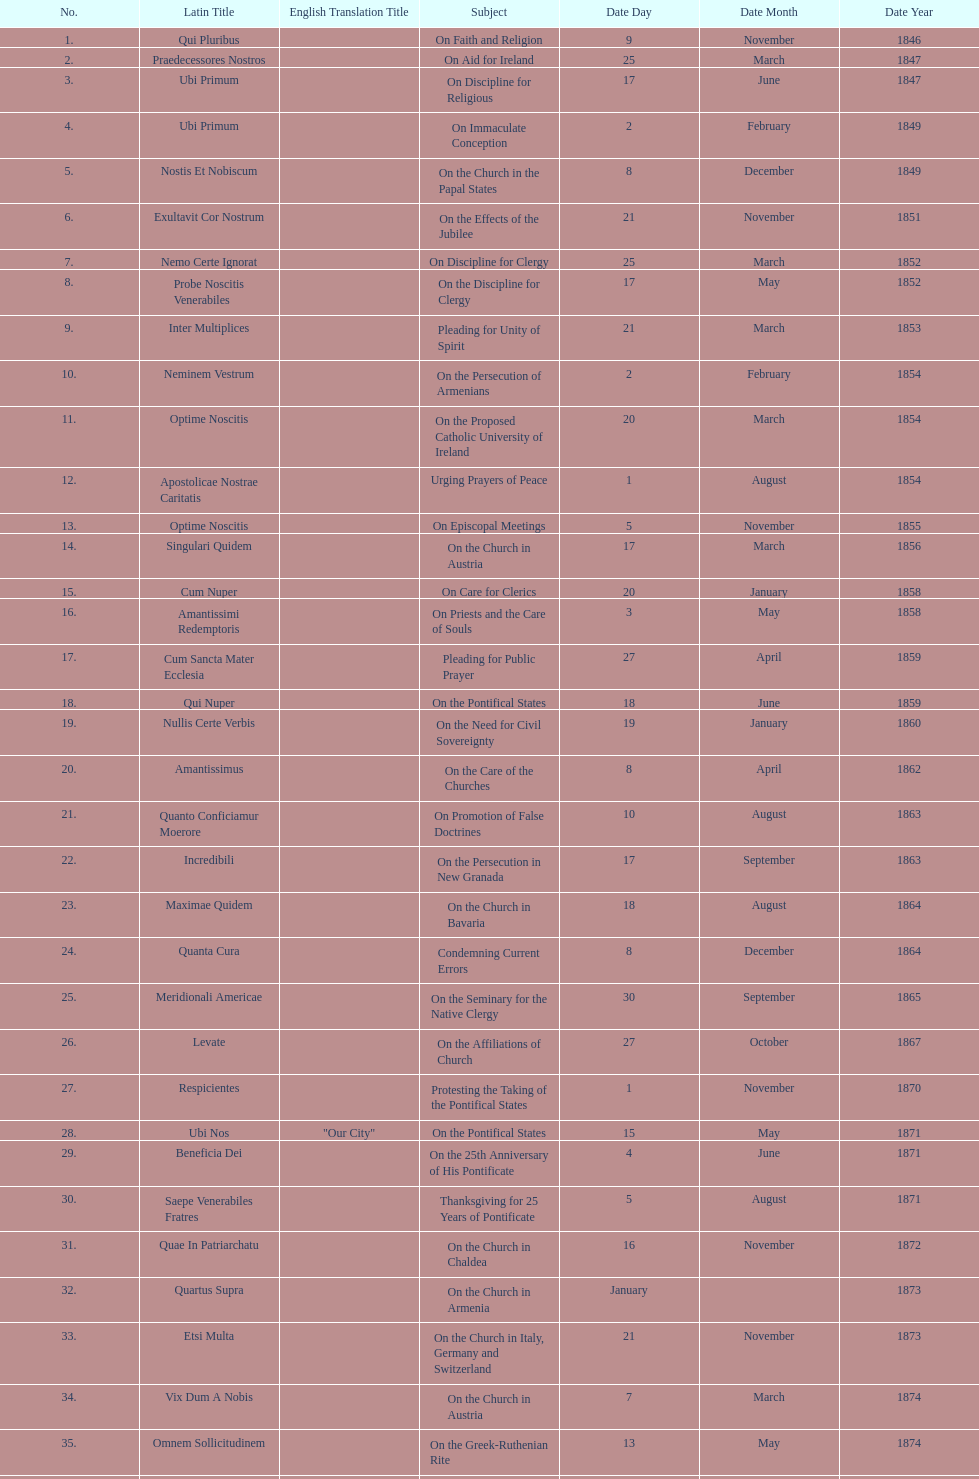What is the last title? Graves Ac Diuturnae. 